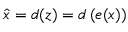<formula> <loc_0><loc_0><loc_500><loc_500>\hat { x } = d ( z ) = d \left ( e ( x ) \right )</formula> 